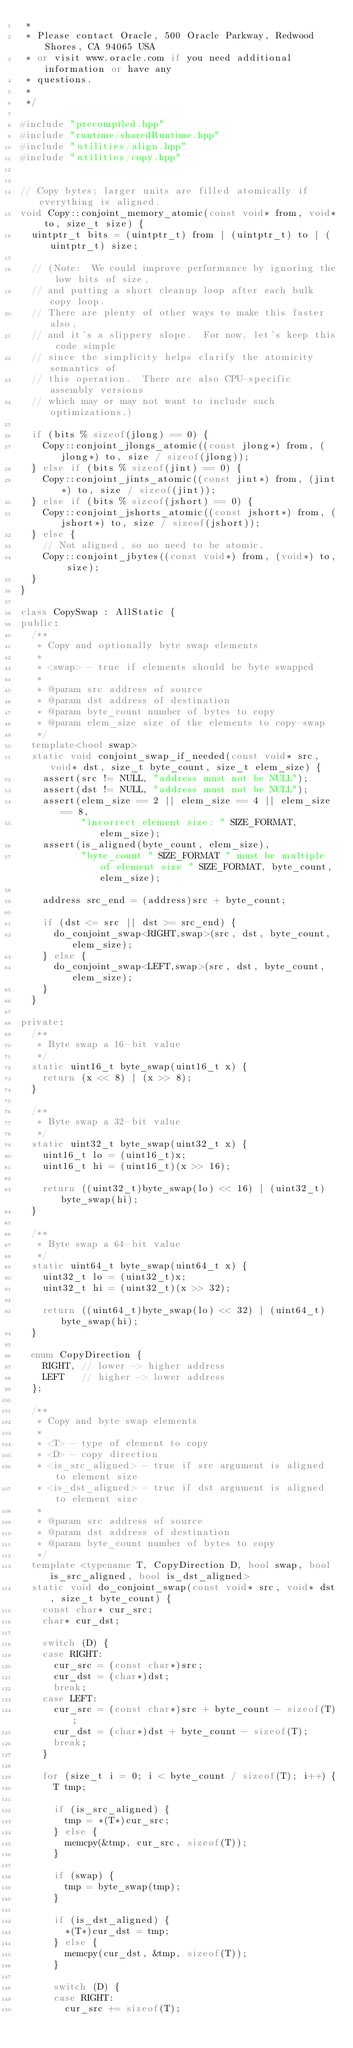Convert code to text. <code><loc_0><loc_0><loc_500><loc_500><_C++_> *
 * Please contact Oracle, 500 Oracle Parkway, Redwood Shores, CA 94065 USA
 * or visit www.oracle.com if you need additional information or have any
 * questions.
 *
 */

#include "precompiled.hpp"
#include "runtime/sharedRuntime.hpp"
#include "utilities/align.hpp"
#include "utilities/copy.hpp"


// Copy bytes; larger units are filled atomically if everything is aligned.
void Copy::conjoint_memory_atomic(const void* from, void* to, size_t size) {
  uintptr_t bits = (uintptr_t) from | (uintptr_t) to | (uintptr_t) size;

  // (Note:  We could improve performance by ignoring the low bits of size,
  // and putting a short cleanup loop after each bulk copy loop.
  // There are plenty of other ways to make this faster also,
  // and it's a slippery slope.  For now, let's keep this code simple
  // since the simplicity helps clarify the atomicity semantics of
  // this operation.  There are also CPU-specific assembly versions
  // which may or may not want to include such optimizations.)

  if (bits % sizeof(jlong) == 0) {
    Copy::conjoint_jlongs_atomic((const jlong*) from, (jlong*) to, size / sizeof(jlong));
  } else if (bits % sizeof(jint) == 0) {
    Copy::conjoint_jints_atomic((const jint*) from, (jint*) to, size / sizeof(jint));
  } else if (bits % sizeof(jshort) == 0) {
    Copy::conjoint_jshorts_atomic((const jshort*) from, (jshort*) to, size / sizeof(jshort));
  } else {
    // Not aligned, so no need to be atomic.
    Copy::conjoint_jbytes((const void*) from, (void*) to, size);
  }
}

class CopySwap : AllStatic {
public:
  /**
   * Copy and optionally byte swap elements
   *
   * <swap> - true if elements should be byte swapped
   *
   * @param src address of source
   * @param dst address of destination
   * @param byte_count number of bytes to copy
   * @param elem_size size of the elements to copy-swap
   */
  template<bool swap>
  static void conjoint_swap_if_needed(const void* src, void* dst, size_t byte_count, size_t elem_size) {
    assert(src != NULL, "address must not be NULL");
    assert(dst != NULL, "address must not be NULL");
    assert(elem_size == 2 || elem_size == 4 || elem_size == 8,
           "incorrect element size: " SIZE_FORMAT, elem_size);
    assert(is_aligned(byte_count, elem_size),
           "byte_count " SIZE_FORMAT " must be multiple of element size " SIZE_FORMAT, byte_count, elem_size);

    address src_end = (address)src + byte_count;

    if (dst <= src || dst >= src_end) {
      do_conjoint_swap<RIGHT,swap>(src, dst, byte_count, elem_size);
    } else {
      do_conjoint_swap<LEFT,swap>(src, dst, byte_count, elem_size);
    }
  }

private:
  /**
   * Byte swap a 16-bit value
   */
  static uint16_t byte_swap(uint16_t x) {
    return (x << 8) | (x >> 8);
  }

  /**
   * Byte swap a 32-bit value
   */
  static uint32_t byte_swap(uint32_t x) {
    uint16_t lo = (uint16_t)x;
    uint16_t hi = (uint16_t)(x >> 16);

    return ((uint32_t)byte_swap(lo) << 16) | (uint32_t)byte_swap(hi);
  }

  /**
   * Byte swap a 64-bit value
   */
  static uint64_t byte_swap(uint64_t x) {
    uint32_t lo = (uint32_t)x;
    uint32_t hi = (uint32_t)(x >> 32);

    return ((uint64_t)byte_swap(lo) << 32) | (uint64_t)byte_swap(hi);
  }

  enum CopyDirection {
    RIGHT, // lower -> higher address
    LEFT   // higher -> lower address
  };

  /**
   * Copy and byte swap elements
   *
   * <T> - type of element to copy
   * <D> - copy direction
   * <is_src_aligned> - true if src argument is aligned to element size
   * <is_dst_aligned> - true if dst argument is aligned to element size
   *
   * @param src address of source
   * @param dst address of destination
   * @param byte_count number of bytes to copy
   */
  template <typename T, CopyDirection D, bool swap, bool is_src_aligned, bool is_dst_aligned>
  static void do_conjoint_swap(const void* src, void* dst, size_t byte_count) {
    const char* cur_src;
    char* cur_dst;

    switch (D) {
    case RIGHT:
      cur_src = (const char*)src;
      cur_dst = (char*)dst;
      break;
    case LEFT:
      cur_src = (const char*)src + byte_count - sizeof(T);
      cur_dst = (char*)dst + byte_count - sizeof(T);
      break;
    }

    for (size_t i = 0; i < byte_count / sizeof(T); i++) {
      T tmp;

      if (is_src_aligned) {
        tmp = *(T*)cur_src;
      } else {
        memcpy(&tmp, cur_src, sizeof(T));
      }

      if (swap) {
        tmp = byte_swap(tmp);
      }

      if (is_dst_aligned) {
        *(T*)cur_dst = tmp;
      } else {
        memcpy(cur_dst, &tmp, sizeof(T));
      }

      switch (D) {
      case RIGHT:
        cur_src += sizeof(T);</code> 